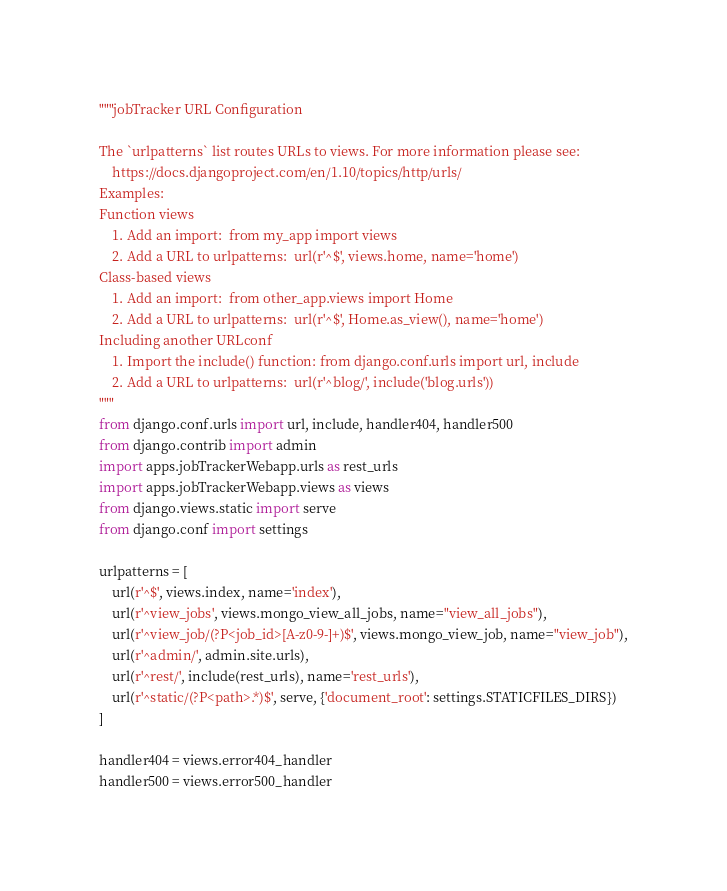<code> <loc_0><loc_0><loc_500><loc_500><_Python_>"""jobTracker URL Configuration

The `urlpatterns` list routes URLs to views. For more information please see:
    https://docs.djangoproject.com/en/1.10/topics/http/urls/
Examples:
Function views
    1. Add an import:  from my_app import views
    2. Add a URL to urlpatterns:  url(r'^$', views.home, name='home')
Class-based views
    1. Add an import:  from other_app.views import Home
    2. Add a URL to urlpatterns:  url(r'^$', Home.as_view(), name='home')
Including another URLconf
    1. Import the include() function: from django.conf.urls import url, include
    2. Add a URL to urlpatterns:  url(r'^blog/', include('blog.urls'))
"""
from django.conf.urls import url, include, handler404, handler500
from django.contrib import admin
import apps.jobTrackerWebapp.urls as rest_urls
import apps.jobTrackerWebapp.views as views
from django.views.static import serve
from django.conf import settings

urlpatterns = [
    url(r'^$', views.index, name='index'),
    url(r'^view_jobs', views.mongo_view_all_jobs, name="view_all_jobs"),
    url(r'^view_job/(?P<job_id>[A-z0-9-]+)$', views.mongo_view_job, name="view_job"),
    url(r'^admin/', admin.site.urls),
    url(r'^rest/', include(rest_urls), name='rest_urls'),
    url(r'^static/(?P<path>.*)$', serve, {'document_root': settings.STATICFILES_DIRS})
]

handler404 = views.error404_handler
handler500 = views.error500_handler</code> 